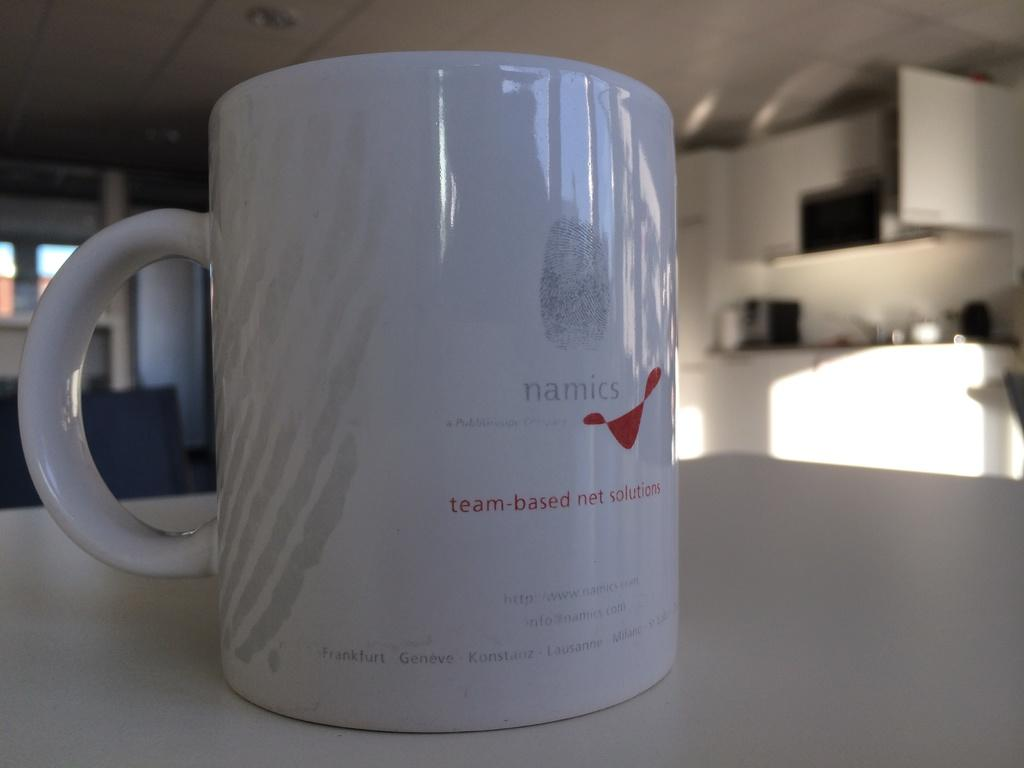Provide a one-sentence caption for the provided image. A mug branded with a company called Namics is sitting on a table. 